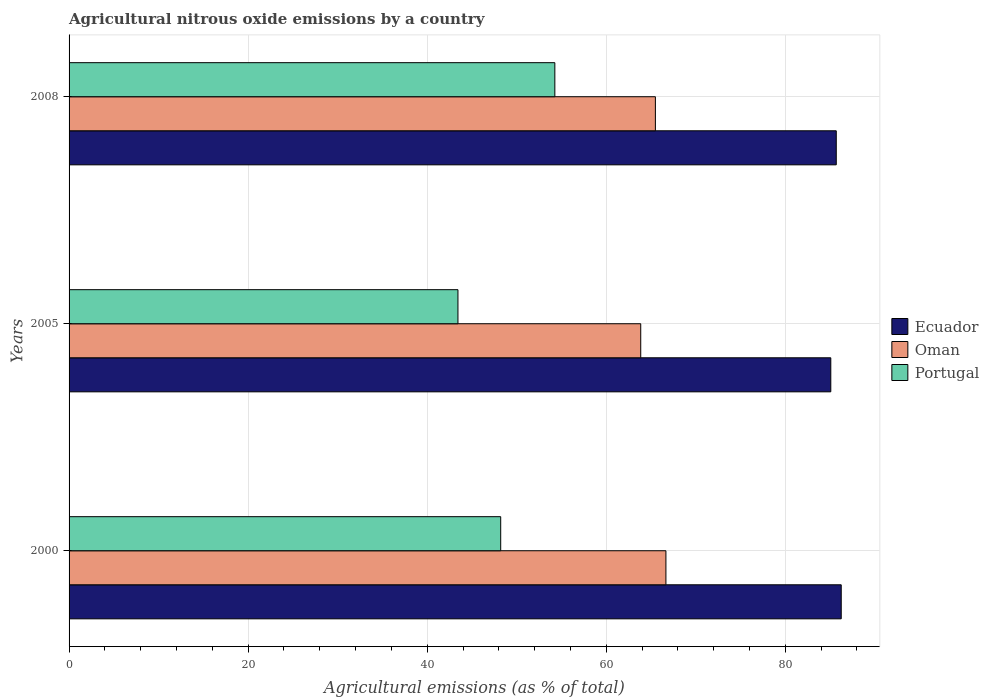How many groups of bars are there?
Ensure brevity in your answer.  3. How many bars are there on the 1st tick from the top?
Provide a short and direct response. 3. What is the amount of agricultural nitrous oxide emitted in Ecuador in 2008?
Your response must be concise. 85.69. Across all years, what is the maximum amount of agricultural nitrous oxide emitted in Ecuador?
Your answer should be very brief. 86.25. Across all years, what is the minimum amount of agricultural nitrous oxide emitted in Oman?
Your response must be concise. 63.85. In which year was the amount of agricultural nitrous oxide emitted in Portugal minimum?
Keep it short and to the point. 2005. What is the total amount of agricultural nitrous oxide emitted in Portugal in the graph?
Your response must be concise. 145.91. What is the difference between the amount of agricultural nitrous oxide emitted in Oman in 2000 and that in 2005?
Make the answer very short. 2.81. What is the difference between the amount of agricultural nitrous oxide emitted in Portugal in 2005 and the amount of agricultural nitrous oxide emitted in Oman in 2008?
Your answer should be compact. -22.05. What is the average amount of agricultural nitrous oxide emitted in Portugal per year?
Offer a terse response. 48.64. In the year 2000, what is the difference between the amount of agricultural nitrous oxide emitted in Oman and amount of agricultural nitrous oxide emitted in Portugal?
Your response must be concise. 18.45. What is the ratio of the amount of agricultural nitrous oxide emitted in Oman in 2000 to that in 2008?
Your response must be concise. 1.02. Is the difference between the amount of agricultural nitrous oxide emitted in Oman in 2000 and 2008 greater than the difference between the amount of agricultural nitrous oxide emitted in Portugal in 2000 and 2008?
Provide a short and direct response. Yes. What is the difference between the highest and the second highest amount of agricultural nitrous oxide emitted in Ecuador?
Ensure brevity in your answer.  0.55. What is the difference between the highest and the lowest amount of agricultural nitrous oxide emitted in Oman?
Provide a succinct answer. 2.81. Is the sum of the amount of agricultural nitrous oxide emitted in Oman in 2000 and 2008 greater than the maximum amount of agricultural nitrous oxide emitted in Ecuador across all years?
Give a very brief answer. Yes. What does the 2nd bar from the top in 2008 represents?
Offer a terse response. Oman. What does the 1st bar from the bottom in 2008 represents?
Give a very brief answer. Ecuador. Are all the bars in the graph horizontal?
Your answer should be very brief. Yes. Are the values on the major ticks of X-axis written in scientific E-notation?
Your answer should be very brief. No. Does the graph contain grids?
Ensure brevity in your answer.  Yes. Where does the legend appear in the graph?
Provide a succinct answer. Center right. How are the legend labels stacked?
Your answer should be compact. Vertical. What is the title of the graph?
Offer a terse response. Agricultural nitrous oxide emissions by a country. What is the label or title of the X-axis?
Your response must be concise. Agricultural emissions (as % of total). What is the label or title of the Y-axis?
Your answer should be compact. Years. What is the Agricultural emissions (as % of total) in Ecuador in 2000?
Your answer should be very brief. 86.25. What is the Agricultural emissions (as % of total) of Oman in 2000?
Your answer should be compact. 66.67. What is the Agricultural emissions (as % of total) of Portugal in 2000?
Your answer should be compact. 48.21. What is the Agricultural emissions (as % of total) of Ecuador in 2005?
Your answer should be very brief. 85.08. What is the Agricultural emissions (as % of total) of Oman in 2005?
Make the answer very short. 63.85. What is the Agricultural emissions (as % of total) in Portugal in 2005?
Ensure brevity in your answer.  43.44. What is the Agricultural emissions (as % of total) of Ecuador in 2008?
Provide a succinct answer. 85.69. What is the Agricultural emissions (as % of total) in Oman in 2008?
Make the answer very short. 65.49. What is the Agricultural emissions (as % of total) in Portugal in 2008?
Make the answer very short. 54.26. Across all years, what is the maximum Agricultural emissions (as % of total) of Ecuador?
Provide a succinct answer. 86.25. Across all years, what is the maximum Agricultural emissions (as % of total) in Oman?
Keep it short and to the point. 66.67. Across all years, what is the maximum Agricultural emissions (as % of total) in Portugal?
Make the answer very short. 54.26. Across all years, what is the minimum Agricultural emissions (as % of total) in Ecuador?
Offer a terse response. 85.08. Across all years, what is the minimum Agricultural emissions (as % of total) of Oman?
Ensure brevity in your answer.  63.85. Across all years, what is the minimum Agricultural emissions (as % of total) of Portugal?
Provide a short and direct response. 43.44. What is the total Agricultural emissions (as % of total) in Ecuador in the graph?
Keep it short and to the point. 257.02. What is the total Agricultural emissions (as % of total) of Oman in the graph?
Ensure brevity in your answer.  196.01. What is the total Agricultural emissions (as % of total) of Portugal in the graph?
Your answer should be very brief. 145.91. What is the difference between the Agricultural emissions (as % of total) in Ecuador in 2000 and that in 2005?
Provide a succinct answer. 1.16. What is the difference between the Agricultural emissions (as % of total) in Oman in 2000 and that in 2005?
Make the answer very short. 2.81. What is the difference between the Agricultural emissions (as % of total) in Portugal in 2000 and that in 2005?
Your answer should be very brief. 4.78. What is the difference between the Agricultural emissions (as % of total) in Ecuador in 2000 and that in 2008?
Offer a very short reply. 0.55. What is the difference between the Agricultural emissions (as % of total) in Oman in 2000 and that in 2008?
Provide a short and direct response. 1.18. What is the difference between the Agricultural emissions (as % of total) in Portugal in 2000 and that in 2008?
Offer a terse response. -6.05. What is the difference between the Agricultural emissions (as % of total) of Ecuador in 2005 and that in 2008?
Ensure brevity in your answer.  -0.61. What is the difference between the Agricultural emissions (as % of total) of Oman in 2005 and that in 2008?
Offer a very short reply. -1.64. What is the difference between the Agricultural emissions (as % of total) in Portugal in 2005 and that in 2008?
Give a very brief answer. -10.82. What is the difference between the Agricultural emissions (as % of total) of Ecuador in 2000 and the Agricultural emissions (as % of total) of Oman in 2005?
Make the answer very short. 22.39. What is the difference between the Agricultural emissions (as % of total) of Ecuador in 2000 and the Agricultural emissions (as % of total) of Portugal in 2005?
Keep it short and to the point. 42.81. What is the difference between the Agricultural emissions (as % of total) of Oman in 2000 and the Agricultural emissions (as % of total) of Portugal in 2005?
Your answer should be compact. 23.23. What is the difference between the Agricultural emissions (as % of total) in Ecuador in 2000 and the Agricultural emissions (as % of total) in Oman in 2008?
Ensure brevity in your answer.  20.76. What is the difference between the Agricultural emissions (as % of total) of Ecuador in 2000 and the Agricultural emissions (as % of total) of Portugal in 2008?
Ensure brevity in your answer.  31.99. What is the difference between the Agricultural emissions (as % of total) of Oman in 2000 and the Agricultural emissions (as % of total) of Portugal in 2008?
Offer a very short reply. 12.41. What is the difference between the Agricultural emissions (as % of total) in Ecuador in 2005 and the Agricultural emissions (as % of total) in Oman in 2008?
Keep it short and to the point. 19.59. What is the difference between the Agricultural emissions (as % of total) in Ecuador in 2005 and the Agricultural emissions (as % of total) in Portugal in 2008?
Provide a succinct answer. 30.82. What is the difference between the Agricultural emissions (as % of total) in Oman in 2005 and the Agricultural emissions (as % of total) in Portugal in 2008?
Offer a terse response. 9.6. What is the average Agricultural emissions (as % of total) in Ecuador per year?
Offer a terse response. 85.67. What is the average Agricultural emissions (as % of total) of Oman per year?
Your answer should be very brief. 65.34. What is the average Agricultural emissions (as % of total) in Portugal per year?
Provide a succinct answer. 48.64. In the year 2000, what is the difference between the Agricultural emissions (as % of total) in Ecuador and Agricultural emissions (as % of total) in Oman?
Provide a short and direct response. 19.58. In the year 2000, what is the difference between the Agricultural emissions (as % of total) of Ecuador and Agricultural emissions (as % of total) of Portugal?
Your answer should be compact. 38.04. In the year 2000, what is the difference between the Agricultural emissions (as % of total) of Oman and Agricultural emissions (as % of total) of Portugal?
Make the answer very short. 18.45. In the year 2005, what is the difference between the Agricultural emissions (as % of total) in Ecuador and Agricultural emissions (as % of total) in Oman?
Ensure brevity in your answer.  21.23. In the year 2005, what is the difference between the Agricultural emissions (as % of total) of Ecuador and Agricultural emissions (as % of total) of Portugal?
Provide a succinct answer. 41.65. In the year 2005, what is the difference between the Agricultural emissions (as % of total) in Oman and Agricultural emissions (as % of total) in Portugal?
Offer a very short reply. 20.42. In the year 2008, what is the difference between the Agricultural emissions (as % of total) of Ecuador and Agricultural emissions (as % of total) of Oman?
Make the answer very short. 20.2. In the year 2008, what is the difference between the Agricultural emissions (as % of total) of Ecuador and Agricultural emissions (as % of total) of Portugal?
Your response must be concise. 31.43. In the year 2008, what is the difference between the Agricultural emissions (as % of total) in Oman and Agricultural emissions (as % of total) in Portugal?
Ensure brevity in your answer.  11.23. What is the ratio of the Agricultural emissions (as % of total) of Ecuador in 2000 to that in 2005?
Make the answer very short. 1.01. What is the ratio of the Agricultural emissions (as % of total) in Oman in 2000 to that in 2005?
Give a very brief answer. 1.04. What is the ratio of the Agricultural emissions (as % of total) in Portugal in 2000 to that in 2005?
Keep it short and to the point. 1.11. What is the ratio of the Agricultural emissions (as % of total) of Ecuador in 2000 to that in 2008?
Give a very brief answer. 1.01. What is the ratio of the Agricultural emissions (as % of total) of Portugal in 2000 to that in 2008?
Keep it short and to the point. 0.89. What is the ratio of the Agricultural emissions (as % of total) in Oman in 2005 to that in 2008?
Ensure brevity in your answer.  0.97. What is the ratio of the Agricultural emissions (as % of total) of Portugal in 2005 to that in 2008?
Offer a terse response. 0.8. What is the difference between the highest and the second highest Agricultural emissions (as % of total) in Ecuador?
Ensure brevity in your answer.  0.55. What is the difference between the highest and the second highest Agricultural emissions (as % of total) in Oman?
Your answer should be compact. 1.18. What is the difference between the highest and the second highest Agricultural emissions (as % of total) in Portugal?
Your answer should be compact. 6.05. What is the difference between the highest and the lowest Agricultural emissions (as % of total) of Ecuador?
Offer a very short reply. 1.16. What is the difference between the highest and the lowest Agricultural emissions (as % of total) of Oman?
Offer a very short reply. 2.81. What is the difference between the highest and the lowest Agricultural emissions (as % of total) of Portugal?
Make the answer very short. 10.82. 